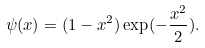<formula> <loc_0><loc_0><loc_500><loc_500>\psi ( x ) = ( 1 - x ^ { 2 } ) \exp ( - \frac { x ^ { 2 } } { 2 } ) .</formula> 